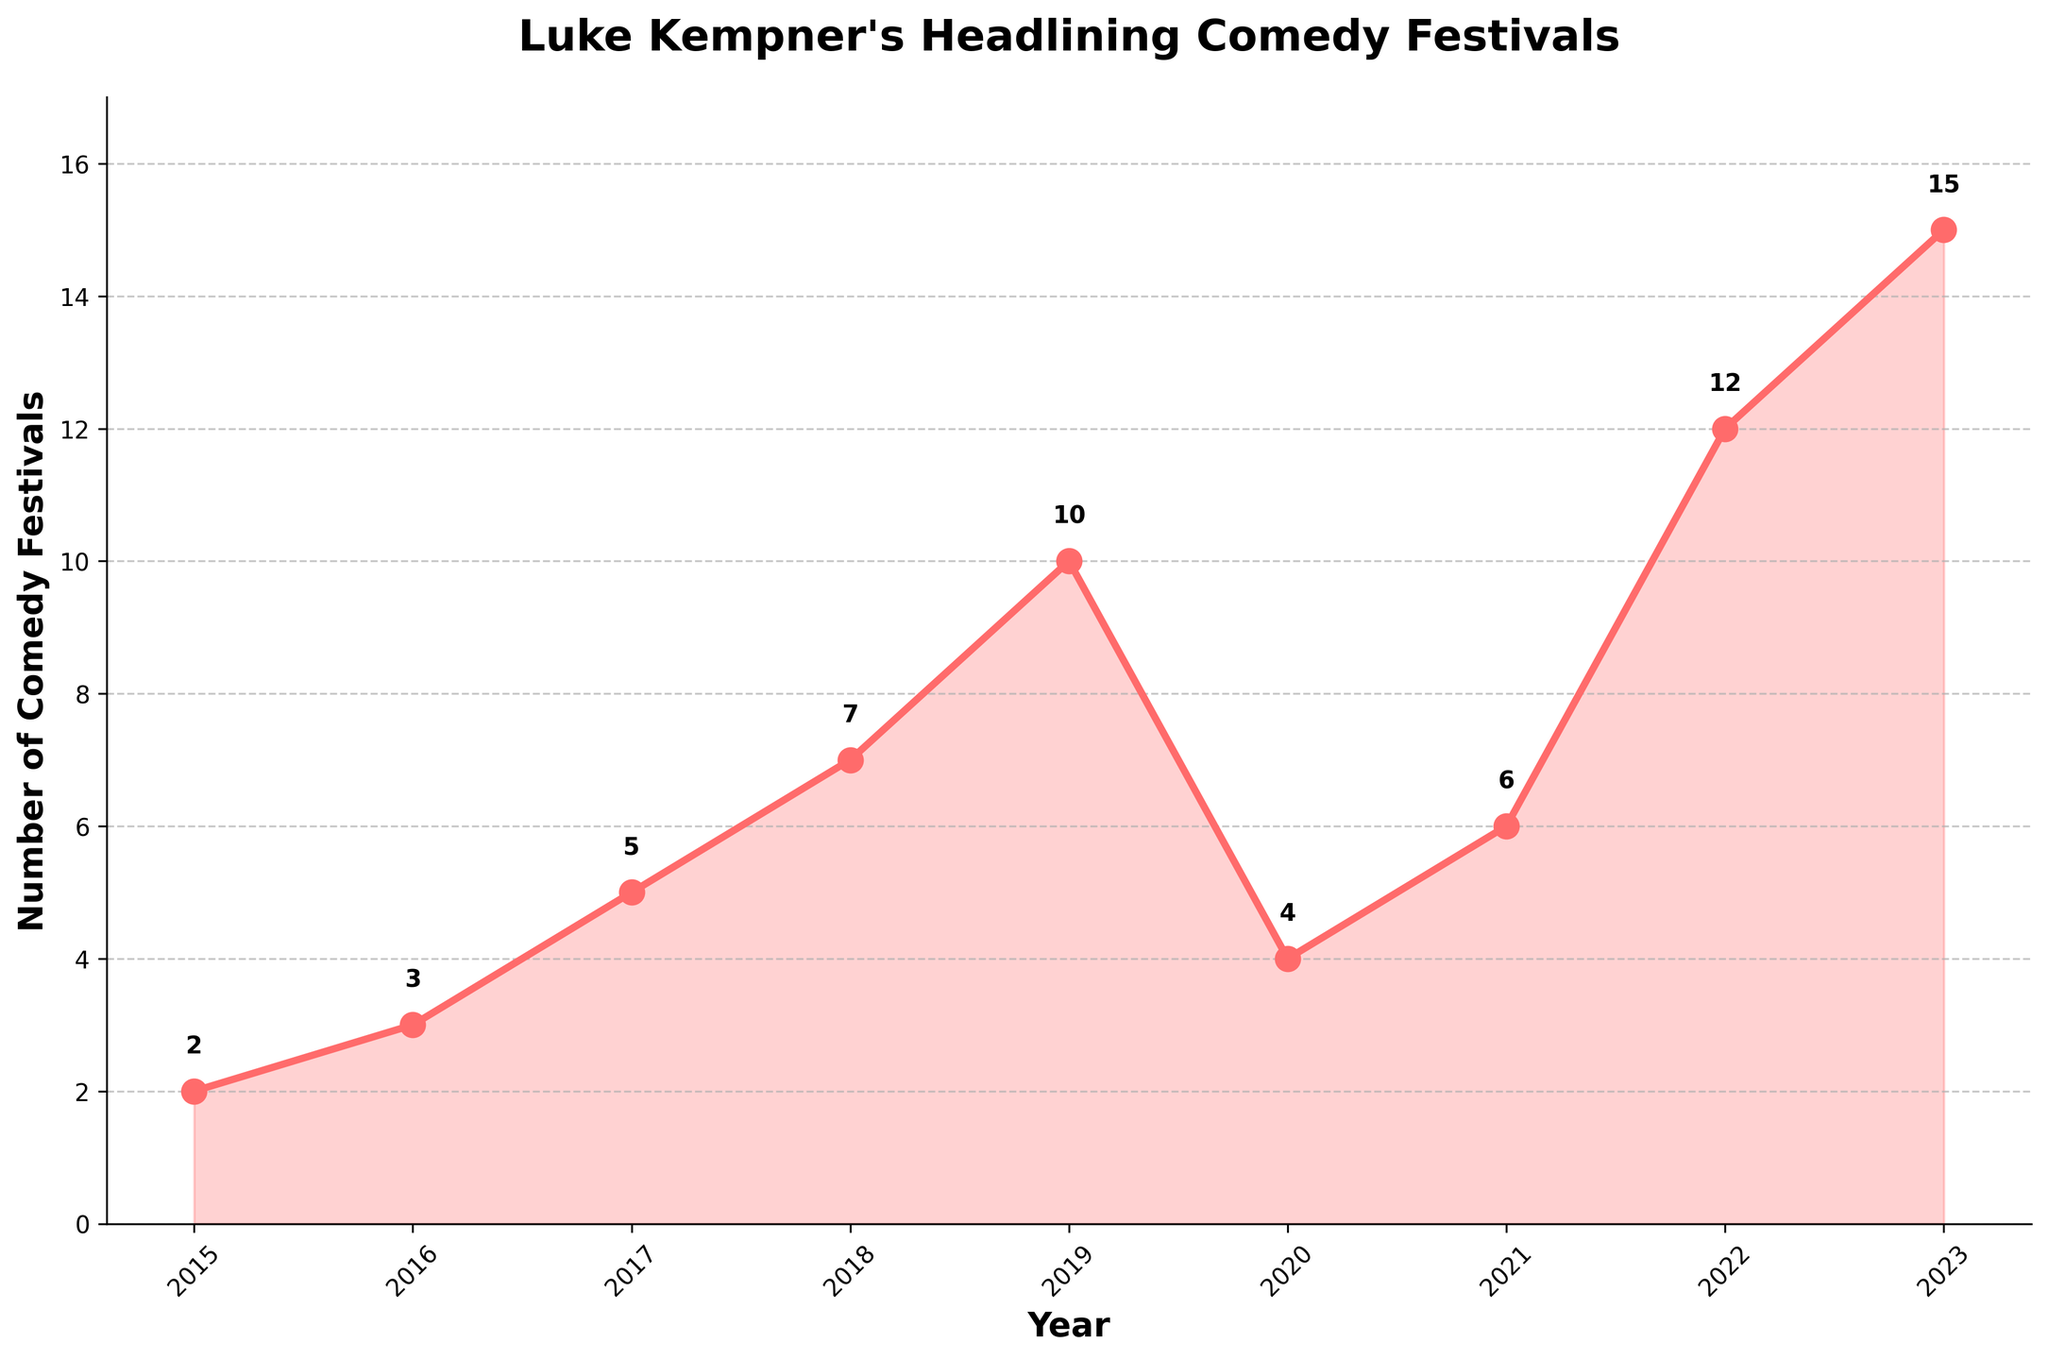What's the trend in the number of comedy festivals from 2015 to 2019? From 2015 to 2019, we see a consistent increase in the number of comedy festivals headlined by Luke Kempner. It started from 2 in 2015, then increased every year to 3 in 2016, 5 in 2017, 7 in 2018, and reached 10 in 2019.
Answer: Consistent increase What happened to the number of comedy festivals in 2020 compared to 2019? The number of comedy festivals in 2020 decreased compared to 2019. It dropped from 10 festivals in 2019 to 4 festivals in 2020.
Answer: Decreased Which year had the highest number of comedy festivals? The highest number of comedy festivals was in 2023, with a total of 15 festivals.
Answer: 2023 What is the total number of comedy festivals from 2015 to 2023? To find the total number of comedy festivals, sum up the values from each year: 2 + 3 + 5 + 7 + 10 + 4 + 6 + 12 + 15. The total is 64 festivals.
Answer: 64 How many more comedy festivals were there in 2023 compared to 2016? In 2023, there were 15 festivals, and in 2016 there were 3. To find the difference, subtract 3 from 15: 15 - 3 = 12. Hence, there were 12 more festivals in 2023 compared to 2016.
Answer: 12 What can be said about the number of comedy festivals in 2022 compared to 2018? The number of comedy festivals in 2022 (12) is significantly higher than in 2018 (7).
Answer: Higher Which years experienced a decline in the number of comedy festivals compared to the previous year? The years 2020 experienced a decline compared to the previous year. The number of comedy festivals dropped from 10 in 2019 to 4 in 2020.
Answer: 2020 What is the overall trend from 2015 to 2023 despite the decline in 2020? Despite the decline in 2020, the overall trend from 2015 to 2023 shows an increase in the number of comedy festivals headlined by Luke Kempner.
Answer: Increasing Between which consecutive years was the largest increase in the number of comedy festivals? The largest increase in the number of comedy festivals occurred between 2022 and 2023, going from 12 festivals in 2022 to 15 festivals in 2023, an increase of 3 festivals.
Answer: 2022 to 2023 